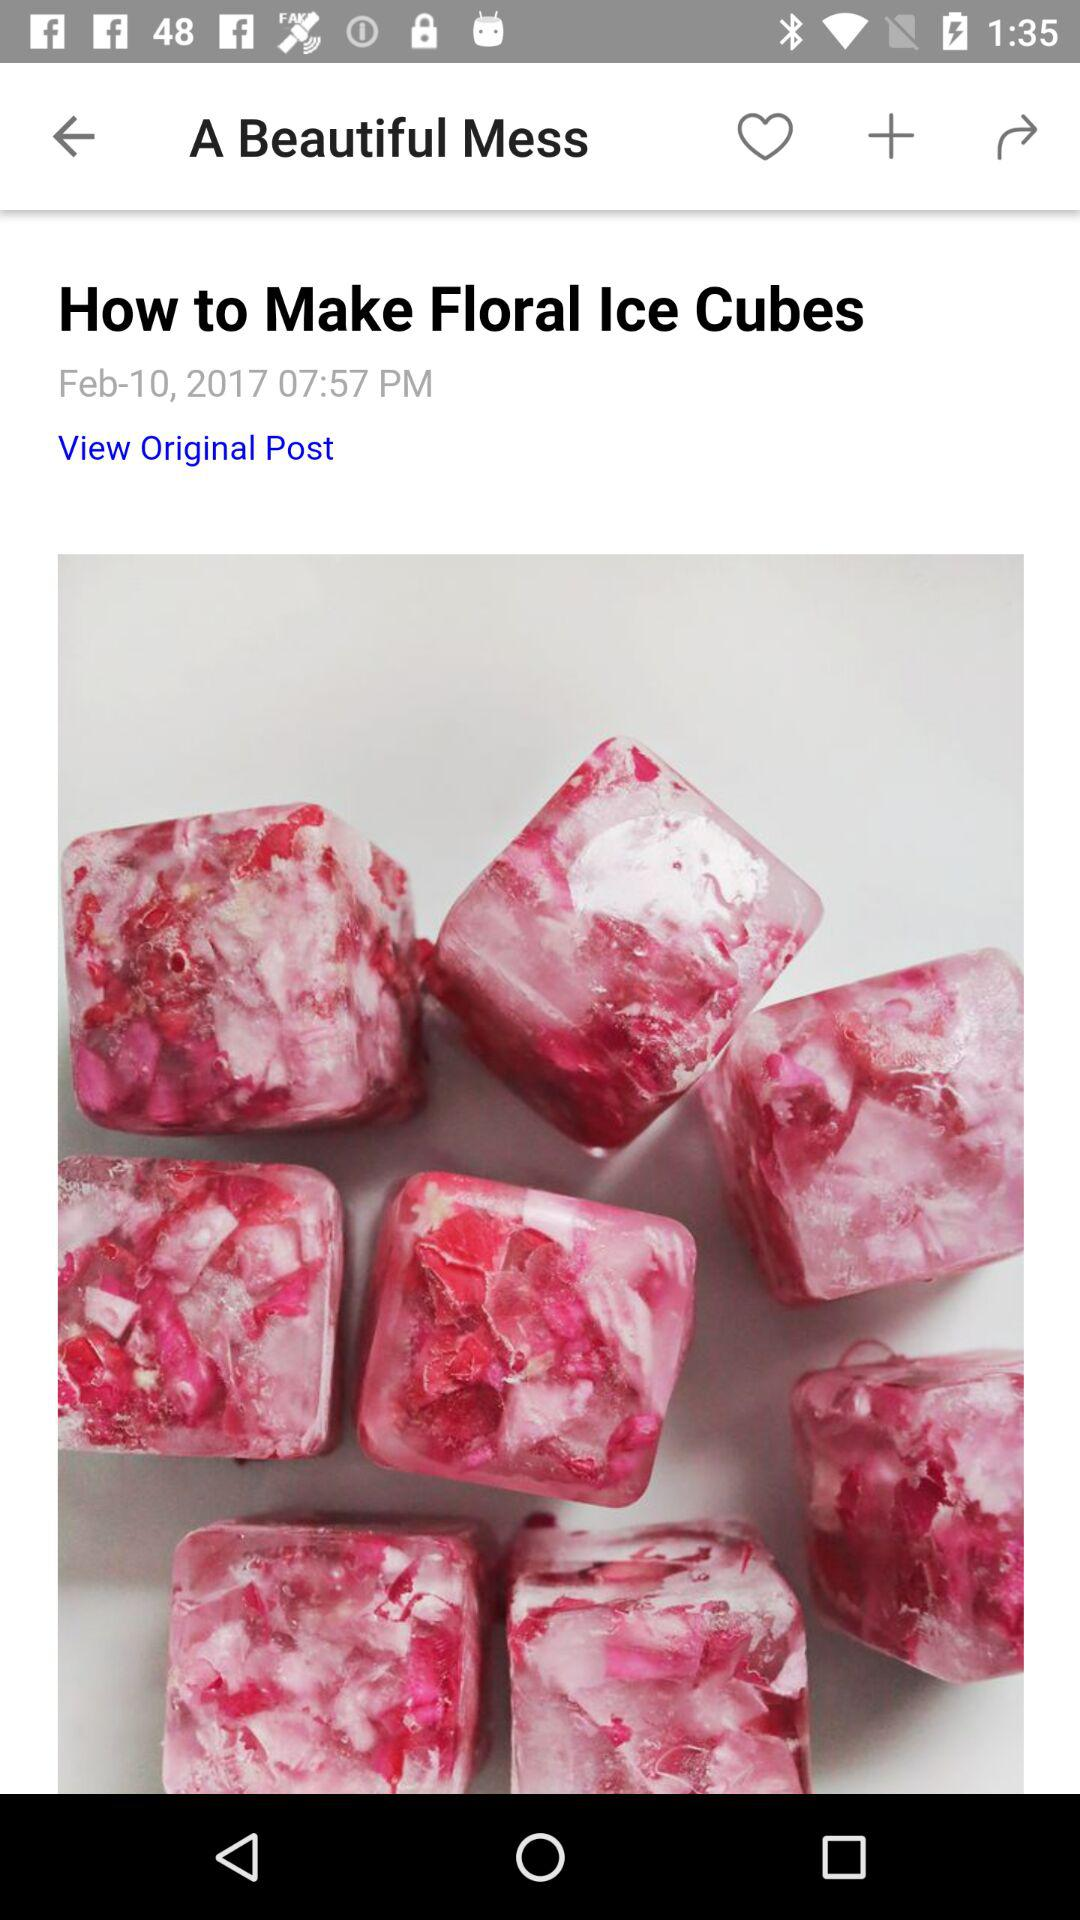What is the time of posting? The time is 07:57 PM. 